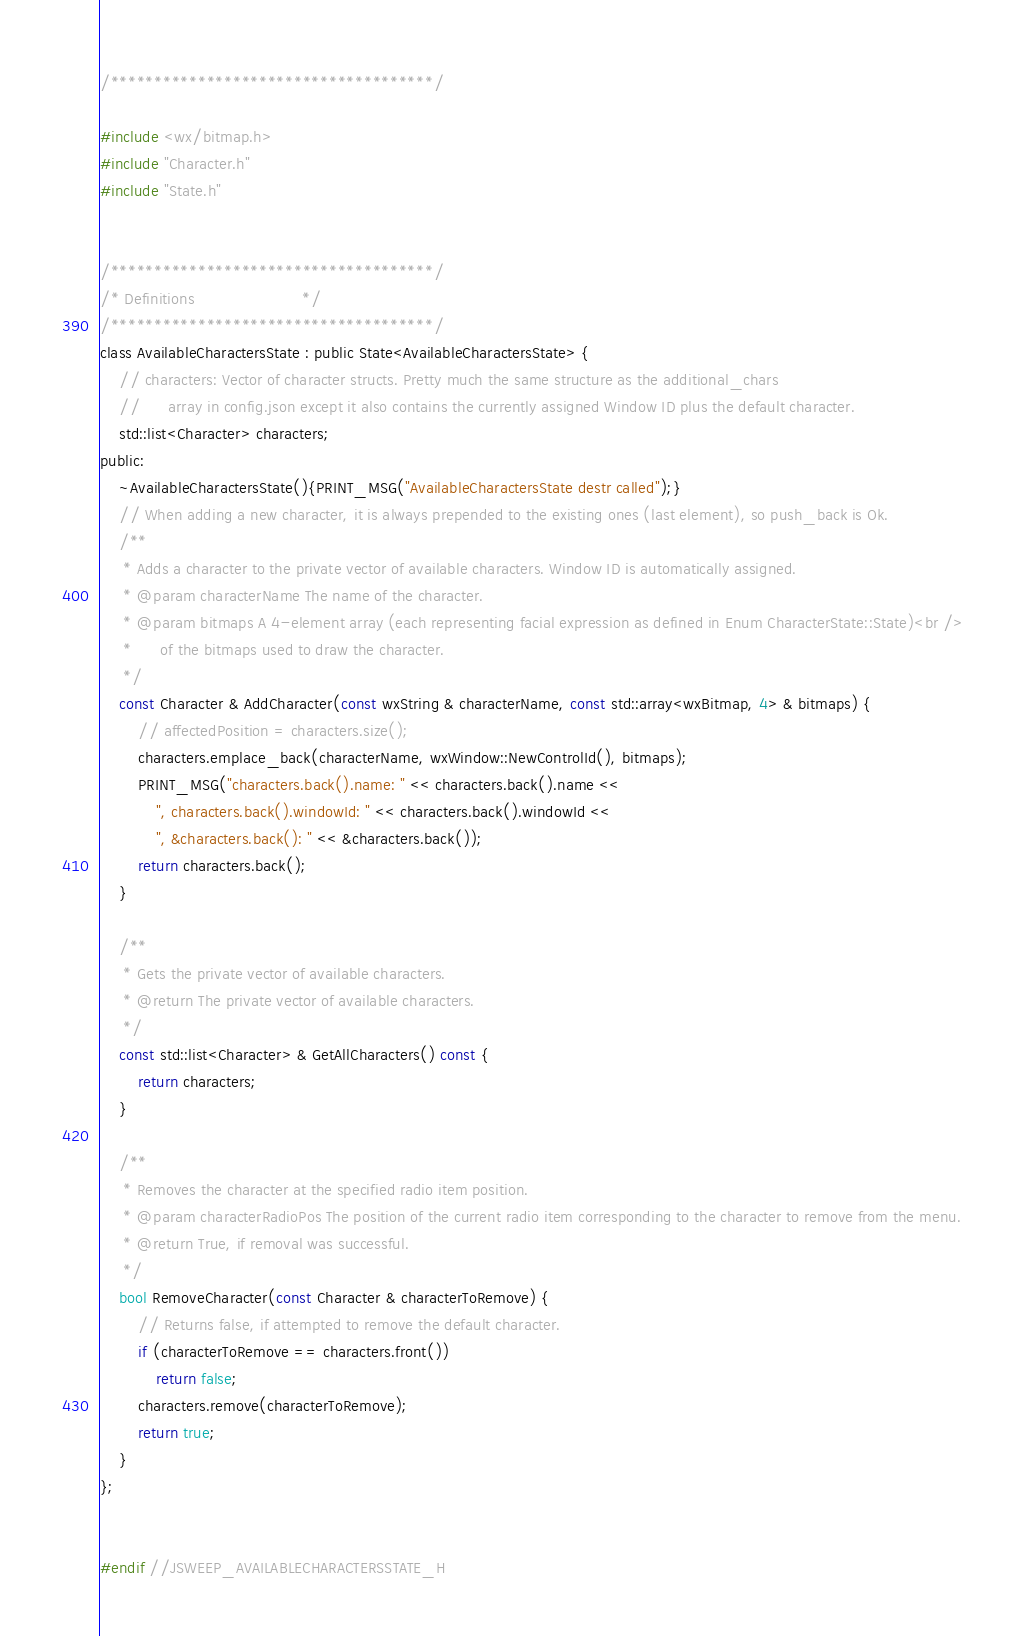<code> <loc_0><loc_0><loc_500><loc_500><_C_>/*************************************/

#include <wx/bitmap.h>
#include "Character.h"
#include "State.h"


/*************************************/
/* Definitions                       */
/*************************************/
class AvailableCharactersState : public State<AvailableCharactersState> {
    // characters: Vector of character structs. Pretty much the same structure as the additional_chars
    //      array in config.json except it also contains the currently assigned Window ID plus the default character.
    std::list<Character> characters;
public:
    ~AvailableCharactersState(){PRINT_MSG("AvailableCharactersState destr called");}
    // When adding a new character, it is always prepended to the existing ones (last element), so push_back is Ok.
    /**
     * Adds a character to the private vector of available characters. Window ID is automatically assigned.
     * @param characterName The name of the character.
     * @param bitmaps A 4-element array (each representing facial expression as defined in Enum CharacterState::State)<br />
     *      of the bitmaps used to draw the character.
     */
    const Character & AddCharacter(const wxString & characterName, const std::array<wxBitmap, 4> & bitmaps) {
        // affectedPosition = characters.size();
        characters.emplace_back(characterName, wxWindow::NewControlId(), bitmaps);
        PRINT_MSG("characters.back().name: " << characters.back().name <<
            ", characters.back().windowId: " << characters.back().windowId <<
            ", &characters.back(): " << &characters.back());
        return characters.back();
    }

    /**
     * Gets the private vector of available characters.
     * @return The private vector of available characters.
     */
    const std::list<Character> & GetAllCharacters() const {
        return characters;
    }

    /**
     * Removes the character at the specified radio item position.
     * @param characterRadioPos The position of the current radio item corresponding to the character to remove from the menu.
     * @return True, if removal was successful.
     */
    bool RemoveCharacter(const Character & characterToRemove) {
        // Returns false, if attempted to remove the default character.
        if (characterToRemove == characters.front())
            return false;
        characters.remove(characterToRemove);
        return true;
    }
};


#endif //JSWEEP_AVAILABLECHARACTERSSTATE_H
</code> 